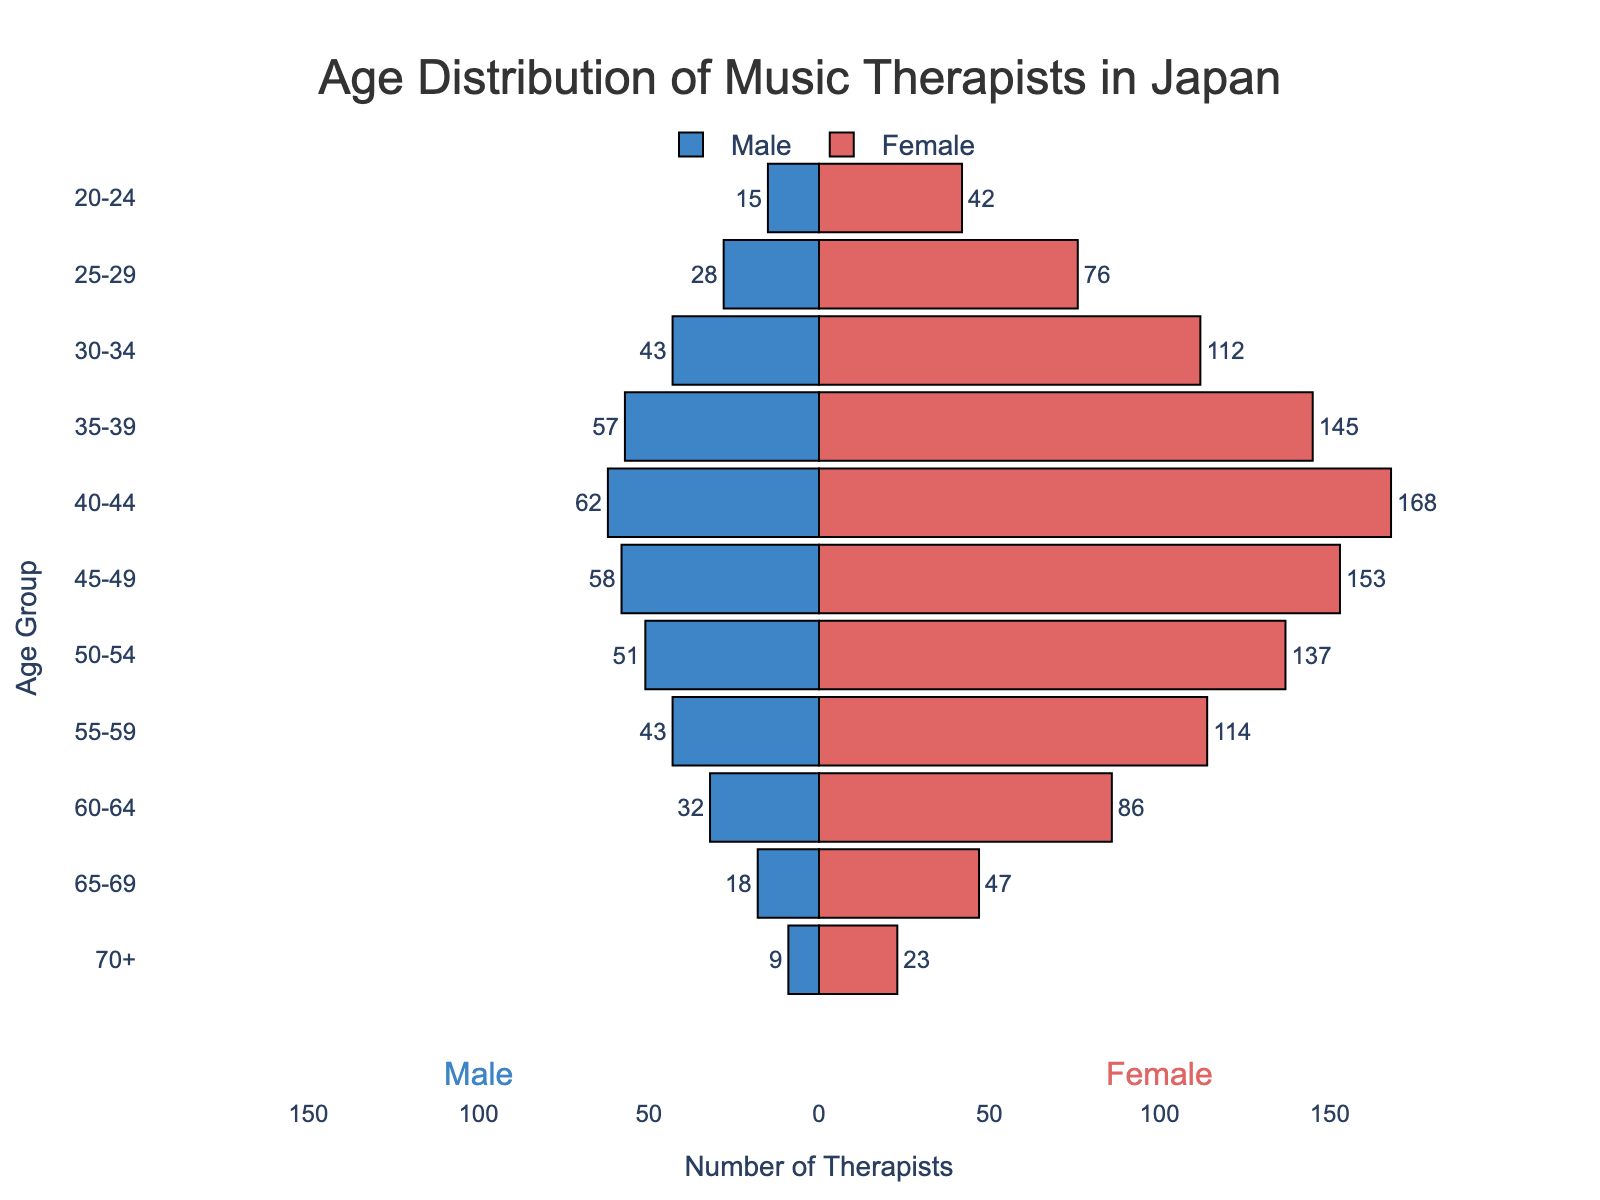What is the title of the figure? The title of a figure is usually positioned at the top and provides an overview of what the figure represents. In this case, it clearly states "Age Distribution of Music Therapists in Japan."
Answer: Age Distribution of Music Therapists in Japan Which age group has the highest number of female therapists? To find this, look at the longest bar on the right side of the population pyramid (the female side) and identify its corresponding age group. The longest bar is at the "40-44" age group.
Answer: 40-44 How many male therapists are in the 50-54 age group? On the male side (left side), find the "50-54" age group and read off the value. It shows that the bar goes up to -51 (taking the absolute value as counts cannot be negative).
Answer: 51 In the age group of 60-64, which gender has more therapists and by how much? Compare the lengths of the bars for males and females in the "60-64" age group. The female bar is longer at 86 while the male bar shows 32, so subtract the male count from the female count (86 - 32).
Answer: Female, by 54 What is the total number of male and female therapists in the 30-34 age group? Add the number of male therapists (43) to the number of female therapists (112) in the "30-34" age group.
Answer: 155 Which age group has the smallest difference in the number of male and female therapists? Calculate the absolute difference between male and female therapists for each age group and find the minimum. For example: 20-24 (42 - 15 = 27), 25-29 (76 - 28 = 48), ..., 70+ (23 - 9 = 14). The smallest difference is 14 in the "70+" age group.
Answer: 70+ Between males and females, who has fewer therapists in the age group of 25-29 and by how much? Compare the number of male therapists (28) with female therapists (76) in the "25-29" age group. Subtract the smaller number from the larger one (76 - 28).
Answer: Male, by 48 What is the most common age range for both male and female music therapists combined? Determine which age range has the highest combined number of therapists by adding male and female counts for each group. For instance: 20-24 (57), 25-29 (104), 30-34 (155), ..., 70+ (32). The range "40-44" has the highest sum (62 + 168).
Answer: 40-44 How does the number of female therapists in the 45-49 age group compare to the number of female therapists in the 35-39 age group? Look at the female numbers for both age groups: 45-49 (153) and 35-39 (145). Compare these figures directly.
Answer: There are 8 more female therapists in the 45-49 age group compared to the 35-39 age group Is there a noticeable trend in the number of therapists as age increases? Briefly describe. By observing the length of the bars from the top (youngest) to the bottom (oldest), notice that the number of therapists initially rises to a peak around the middle age ranges (40-44 and 45-49) before gradually decreasing.
Answer: There is a rise to a peak around middle ages and then a decline as age increases 